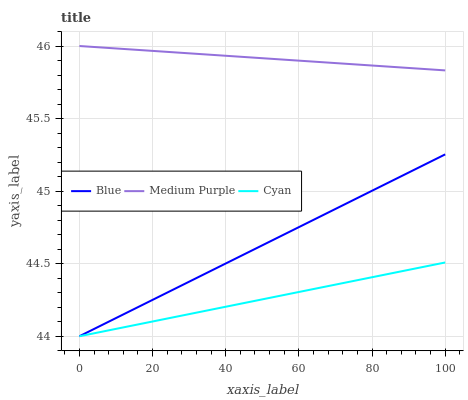Does Cyan have the minimum area under the curve?
Answer yes or no. Yes. Does Medium Purple have the maximum area under the curve?
Answer yes or no. Yes. Does Medium Purple have the minimum area under the curve?
Answer yes or no. No. Does Cyan have the maximum area under the curve?
Answer yes or no. No. Is Blue the smoothest?
Answer yes or no. Yes. Is Medium Purple the roughest?
Answer yes or no. Yes. Is Cyan the smoothest?
Answer yes or no. No. Is Cyan the roughest?
Answer yes or no. No. Does Blue have the lowest value?
Answer yes or no. Yes. Does Medium Purple have the lowest value?
Answer yes or no. No. Does Medium Purple have the highest value?
Answer yes or no. Yes. Does Cyan have the highest value?
Answer yes or no. No. Is Cyan less than Medium Purple?
Answer yes or no. Yes. Is Medium Purple greater than Blue?
Answer yes or no. Yes. Does Cyan intersect Blue?
Answer yes or no. Yes. Is Cyan less than Blue?
Answer yes or no. No. Is Cyan greater than Blue?
Answer yes or no. No. Does Cyan intersect Medium Purple?
Answer yes or no. No. 